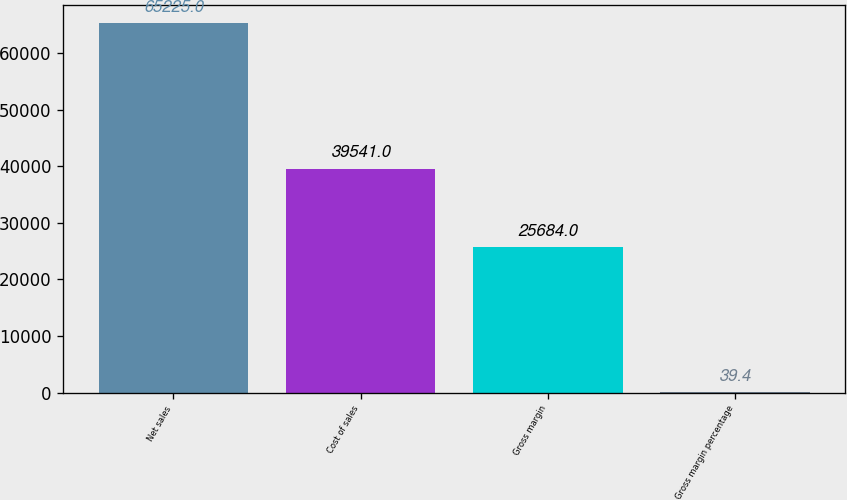Convert chart. <chart><loc_0><loc_0><loc_500><loc_500><bar_chart><fcel>Net sales<fcel>Cost of sales<fcel>Gross margin<fcel>Gross margin percentage<nl><fcel>65225<fcel>39541<fcel>25684<fcel>39.4<nl></chart> 